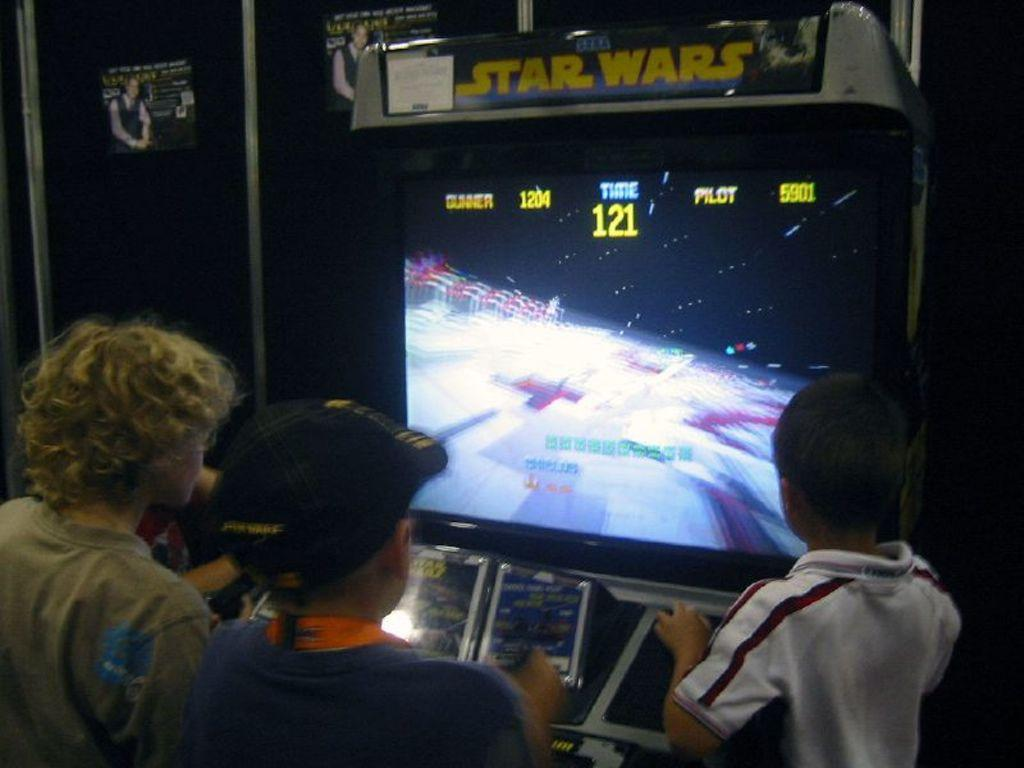What is the main subject of the image? The main subject of the image is a video game screen. How many people are present in the image? There are three boys in the image. What can be seen in addition to the video game screen? There are words visible in the image. Can you describe the overall lighting in the image? The background of the image is dark. What type of objects are present in the image? There are posts in the image. What color of paint is being used by the boys in the image? There is no paint visible in the image, and the boys are not engaged in any painting activity. 